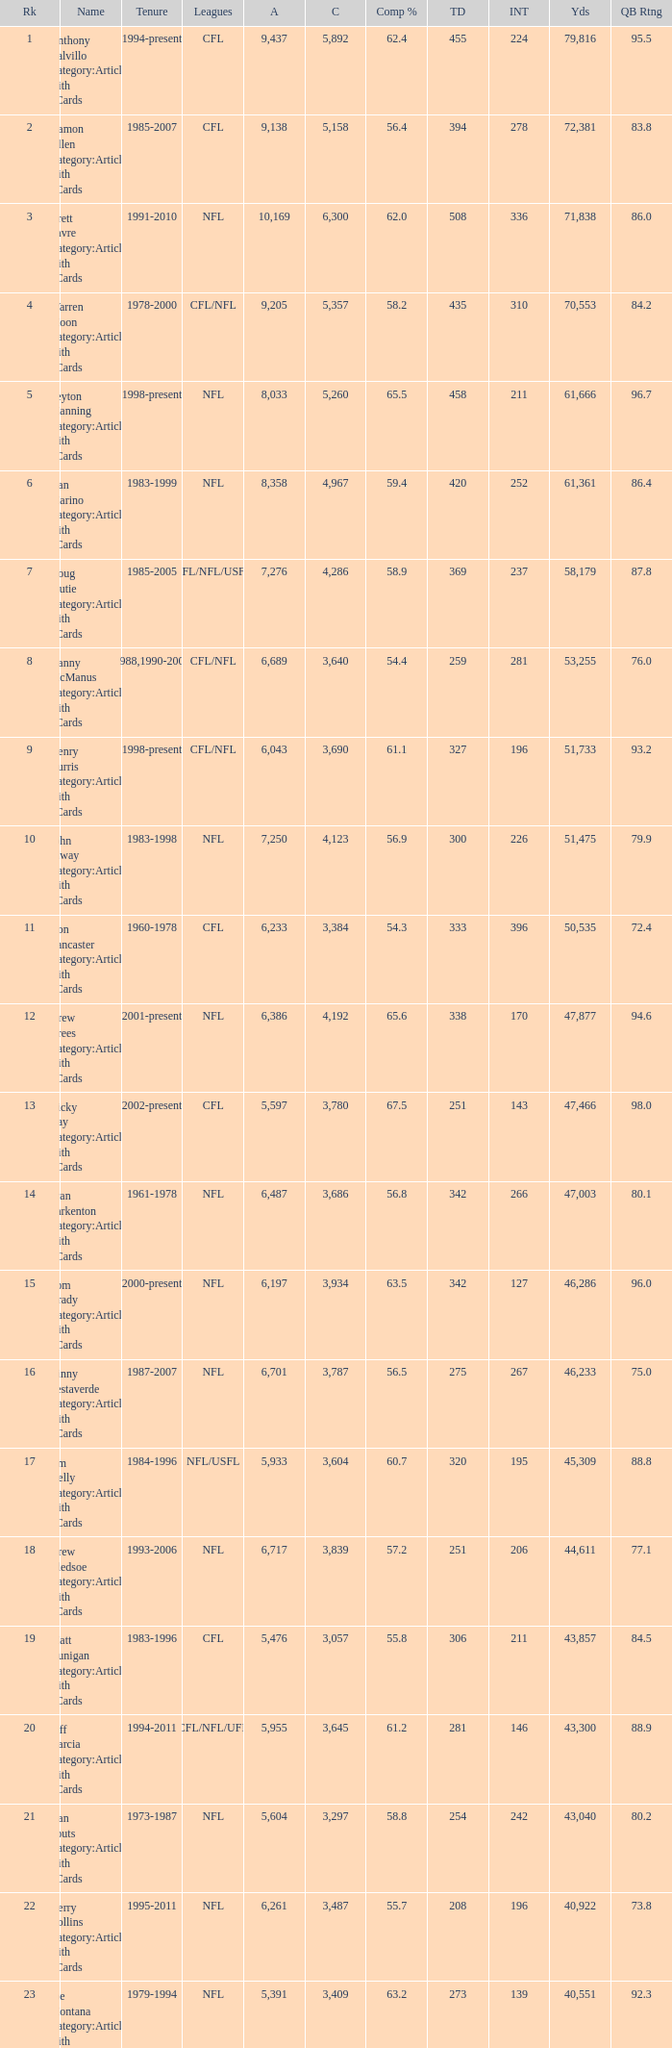What is the rank when there are more than 4,123 completion and the comp percentage is more than 65.6? None. 